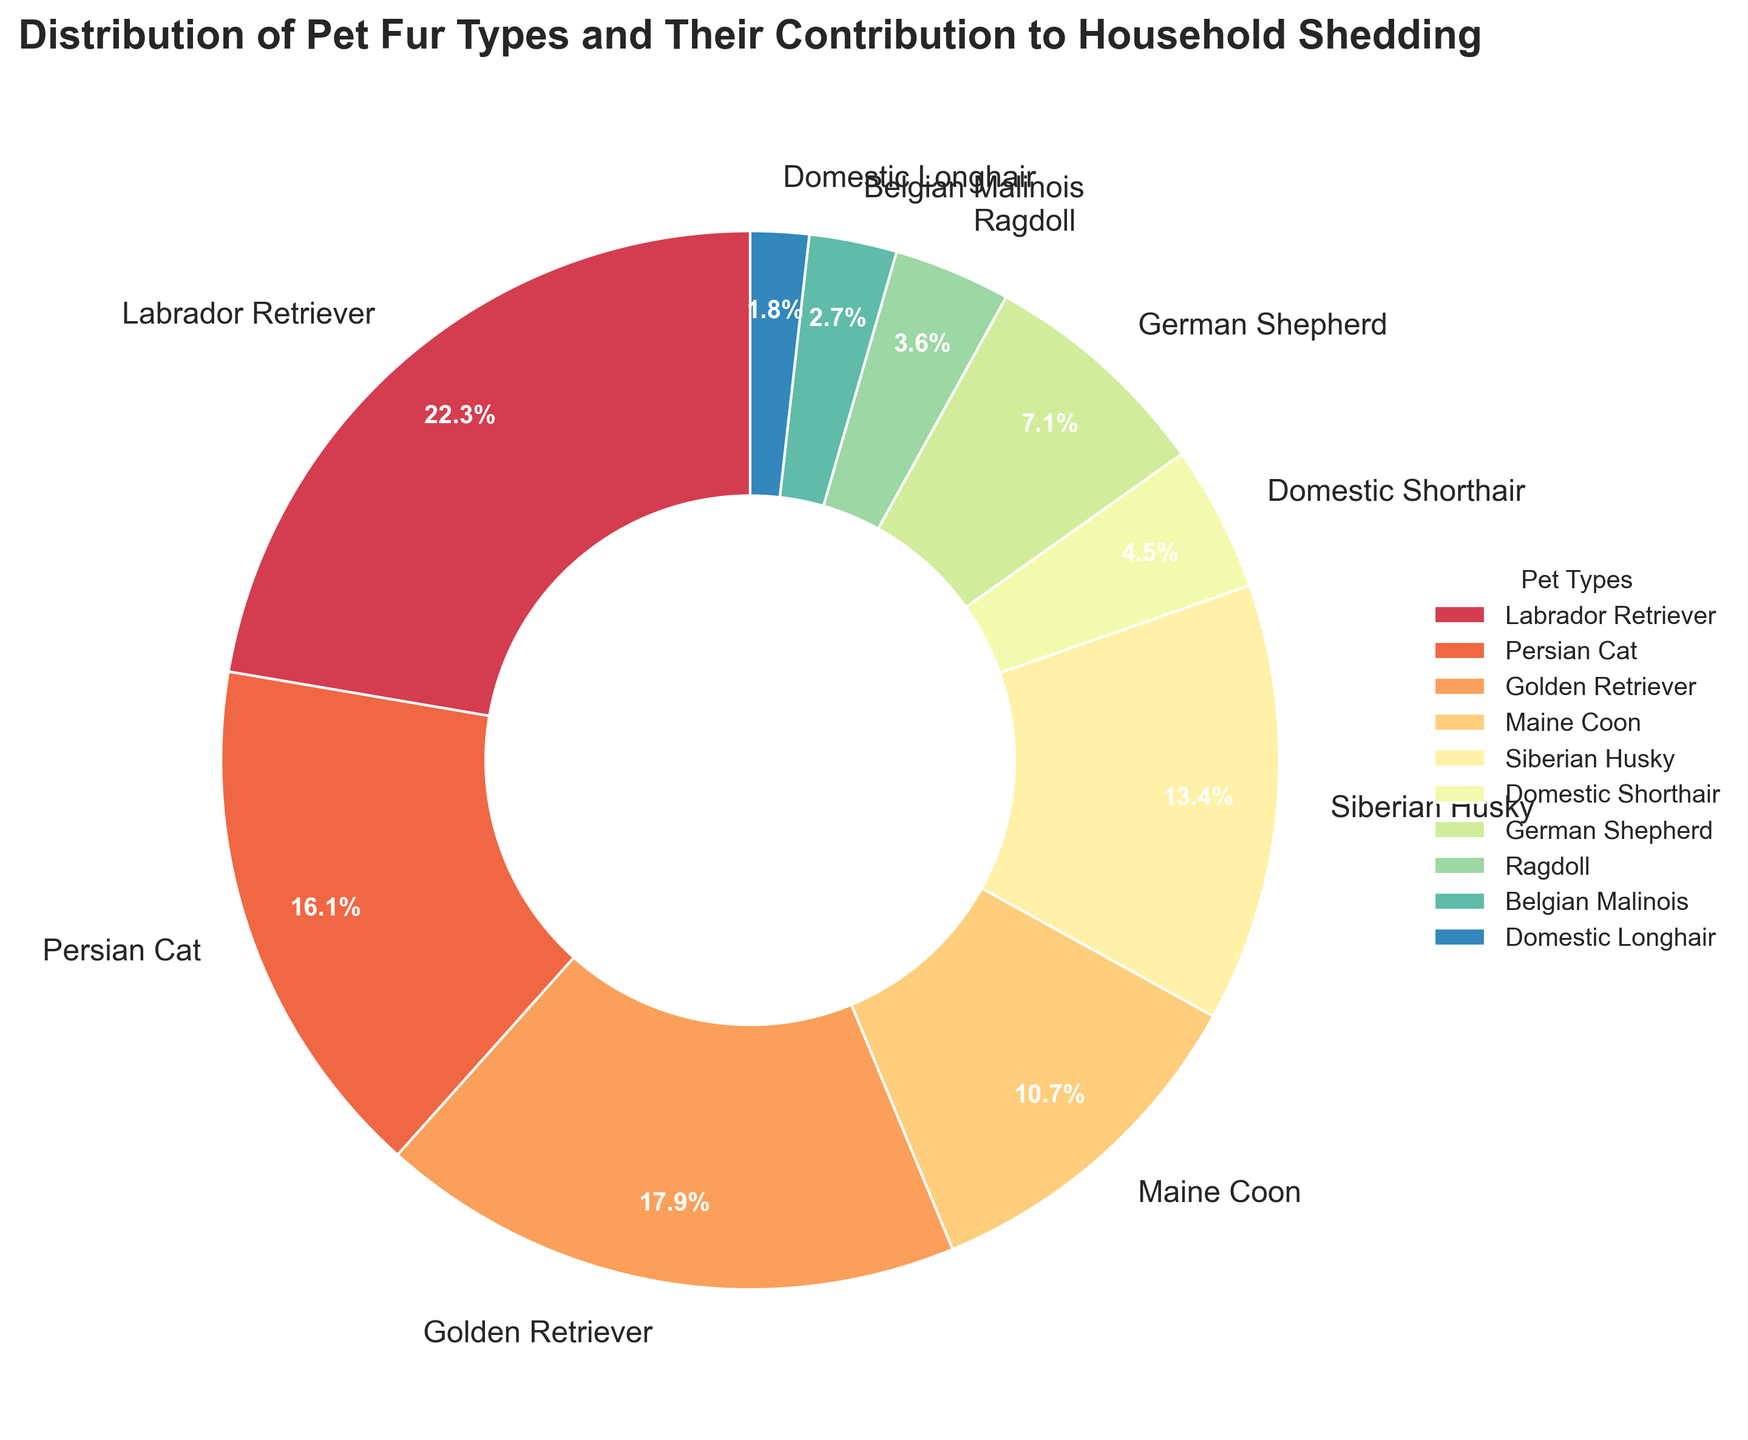What is the percentage contribution of the Labrador Retriever to household shedding? Identify the wedge labeled "Labrador Retriever" in the pie chart and read its corresponding percentage label.
Answer: 25% Which pet type contributes the least to household shedding? Identify the smallest wedge in the pie chart and read its corresponding label.
Answer: Domestic Longhair What is the combined shedding percentage of the Golden Retriever and Siberian Husky? Add the percentages for the Golden Retriever (20%) and the Siberian Husky (15%). 20% + 15% = 35%
Answer: 35% How does the shedding percentage of a German Shepherd compare to that of a Persian Cat? German Shepherd's shedding percentage is 8% and Persian Cat's is 18%. Compare the two values.
Answer: German Shepherd sheds less than Persian Cat What is the total percentage of shedding contributed by all cat types in the chart? Add the percentages for Persian Cat (18%), Maine Coon (12%), Domestic Shorthair (5%), and Ragdoll (4%), and Domestic Longhair (2%). 18% + 12% + 5% + 4% + 2% = 41%
Answer: 41% Which two pet types have the closest shedding percentages? Compare the percentages visually and identify the two wedges with close values. Golden Retriever (20%) and Siberian Husky (15%) look close, but more so are German Shepherd (8%) and Persian Cat (18%).
Answer: Persian Cat and German Shepherd have the closest gap What is the difference in shedding percentage between the pet with the highest shedding and the pet with the lowest shedding? Subtract the lowest percentage (Domestic Longhair, 2%) from the highest percentage (Labrador Retriever, 25%). 25% - 2% = 23%
Answer: 23% What is the average shedding percentage of all dog breeds in the chart? Add the percentages for Labrador Retriever (25%), Golden Retriever (20%), Siberian Husky (15%), German Shepherd (8%), and Belgian Malinois (3%), and divide by the number of dog breeds (5). (25% + 20% + 15% + 8% + 3%) / 5 = 14.2%
Answer: 14.2% What color is associated with the Belgian Malinois in the chart? Identify the segment labeled "Belgian Malinois" and describe its color in natural language.
Answer: Color varies by the colormap used, usually a particular shade visible in the legend 